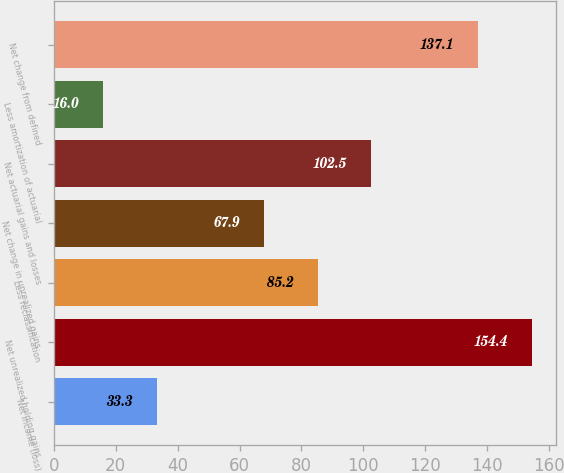Convert chart to OTSL. <chart><loc_0><loc_0><loc_500><loc_500><bar_chart><fcel>Net income (loss)<fcel>Net unrealized holding gains<fcel>Less reclassification<fcel>Net change in unrealized gains<fcel>Net actuarial gains and losses<fcel>Less amortization of actuarial<fcel>Net change from defined<nl><fcel>33.3<fcel>154.4<fcel>85.2<fcel>67.9<fcel>102.5<fcel>16<fcel>137.1<nl></chart> 